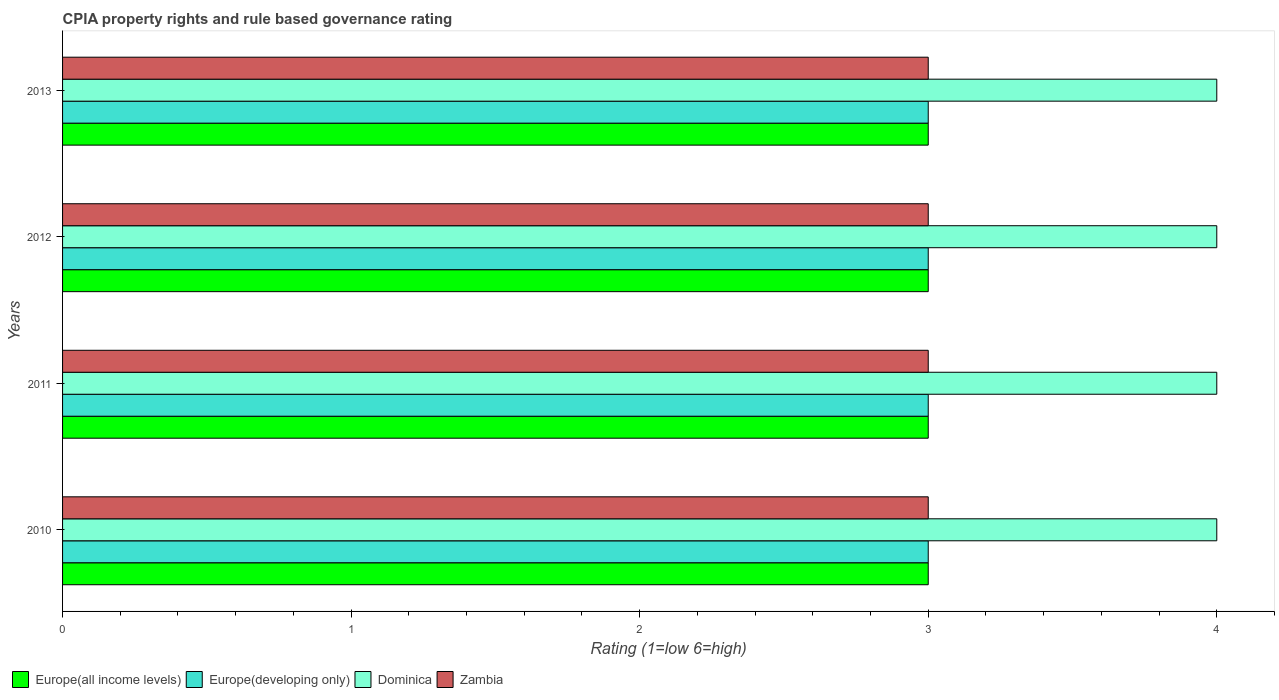How many bars are there on the 4th tick from the bottom?
Provide a succinct answer. 4. What is the label of the 2nd group of bars from the top?
Provide a short and direct response. 2012. What is the CPIA rating in Zambia in 2012?
Keep it short and to the point. 3. Across all years, what is the maximum CPIA rating in Europe(developing only)?
Keep it short and to the point. 3. What is the total CPIA rating in Dominica in the graph?
Keep it short and to the point. 16. In the year 2012, what is the difference between the CPIA rating in Zambia and CPIA rating in Europe(developing only)?
Make the answer very short. 0. In how many years, is the CPIA rating in Zambia greater than 3.4 ?
Keep it short and to the point. 0. What is the ratio of the CPIA rating in Europe(developing only) in 2011 to that in 2013?
Give a very brief answer. 1. Is the difference between the CPIA rating in Zambia in 2010 and 2011 greater than the difference between the CPIA rating in Europe(developing only) in 2010 and 2011?
Keep it short and to the point. No. Is it the case that in every year, the sum of the CPIA rating in Europe(developing only) and CPIA rating in Zambia is greater than the sum of CPIA rating in Europe(all income levels) and CPIA rating in Dominica?
Offer a terse response. No. What does the 2nd bar from the top in 2012 represents?
Give a very brief answer. Dominica. What does the 2nd bar from the bottom in 2010 represents?
Your response must be concise. Europe(developing only). Is it the case that in every year, the sum of the CPIA rating in Dominica and CPIA rating in Zambia is greater than the CPIA rating in Europe(all income levels)?
Ensure brevity in your answer.  Yes. What is the difference between two consecutive major ticks on the X-axis?
Offer a terse response. 1. Are the values on the major ticks of X-axis written in scientific E-notation?
Your answer should be very brief. No. Does the graph contain grids?
Provide a succinct answer. No. How many legend labels are there?
Offer a terse response. 4. How are the legend labels stacked?
Provide a short and direct response. Horizontal. What is the title of the graph?
Your response must be concise. CPIA property rights and rule based governance rating. Does "New Zealand" appear as one of the legend labels in the graph?
Keep it short and to the point. No. What is the Rating (1=low 6=high) of Europe(developing only) in 2010?
Keep it short and to the point. 3. What is the Rating (1=low 6=high) in Zambia in 2010?
Your response must be concise. 3. What is the Rating (1=low 6=high) in Europe(developing only) in 2011?
Offer a very short reply. 3. What is the Rating (1=low 6=high) of Dominica in 2011?
Keep it short and to the point. 4. What is the Rating (1=low 6=high) in Zambia in 2011?
Make the answer very short. 3. What is the Rating (1=low 6=high) of Europe(all income levels) in 2012?
Keep it short and to the point. 3. What is the Rating (1=low 6=high) in Europe(all income levels) in 2013?
Your answer should be very brief. 3. What is the Rating (1=low 6=high) in Zambia in 2013?
Ensure brevity in your answer.  3. Across all years, what is the maximum Rating (1=low 6=high) in Europe(all income levels)?
Your answer should be very brief. 3. Across all years, what is the maximum Rating (1=low 6=high) in Europe(developing only)?
Your answer should be compact. 3. Across all years, what is the maximum Rating (1=low 6=high) of Dominica?
Provide a succinct answer. 4. Across all years, what is the minimum Rating (1=low 6=high) of Zambia?
Ensure brevity in your answer.  3. What is the total Rating (1=low 6=high) of Europe(all income levels) in the graph?
Your answer should be compact. 12. What is the total Rating (1=low 6=high) of Europe(developing only) in the graph?
Offer a very short reply. 12. What is the total Rating (1=low 6=high) in Dominica in the graph?
Offer a terse response. 16. What is the difference between the Rating (1=low 6=high) of Europe(developing only) in 2010 and that in 2011?
Keep it short and to the point. 0. What is the difference between the Rating (1=low 6=high) in Dominica in 2010 and that in 2011?
Your answer should be very brief. 0. What is the difference between the Rating (1=low 6=high) of Zambia in 2010 and that in 2011?
Provide a short and direct response. 0. What is the difference between the Rating (1=low 6=high) in Europe(all income levels) in 2010 and that in 2012?
Keep it short and to the point. 0. What is the difference between the Rating (1=low 6=high) of Europe(developing only) in 2010 and that in 2012?
Give a very brief answer. 0. What is the difference between the Rating (1=low 6=high) of Dominica in 2010 and that in 2012?
Offer a very short reply. 0. What is the difference between the Rating (1=low 6=high) of Europe(all income levels) in 2010 and that in 2013?
Your answer should be very brief. 0. What is the difference between the Rating (1=low 6=high) of Zambia in 2010 and that in 2013?
Give a very brief answer. 0. What is the difference between the Rating (1=low 6=high) in Europe(developing only) in 2011 and that in 2013?
Your response must be concise. 0. What is the difference between the Rating (1=low 6=high) of Europe(developing only) in 2012 and that in 2013?
Offer a very short reply. 0. What is the difference between the Rating (1=low 6=high) of Zambia in 2012 and that in 2013?
Your answer should be compact. 0. What is the difference between the Rating (1=low 6=high) of Europe(all income levels) in 2010 and the Rating (1=low 6=high) of Dominica in 2011?
Your answer should be compact. -1. What is the difference between the Rating (1=low 6=high) of Europe(developing only) in 2010 and the Rating (1=low 6=high) of Zambia in 2011?
Offer a terse response. 0. What is the difference between the Rating (1=low 6=high) in Dominica in 2010 and the Rating (1=low 6=high) in Zambia in 2011?
Make the answer very short. 1. What is the difference between the Rating (1=low 6=high) of Europe(all income levels) in 2010 and the Rating (1=low 6=high) of Europe(developing only) in 2012?
Make the answer very short. 0. What is the difference between the Rating (1=low 6=high) in Europe(developing only) in 2010 and the Rating (1=low 6=high) in Dominica in 2012?
Keep it short and to the point. -1. What is the difference between the Rating (1=low 6=high) of Dominica in 2010 and the Rating (1=low 6=high) of Zambia in 2012?
Offer a very short reply. 1. What is the difference between the Rating (1=low 6=high) in Europe(all income levels) in 2010 and the Rating (1=low 6=high) in Europe(developing only) in 2013?
Give a very brief answer. 0. What is the difference between the Rating (1=low 6=high) of Europe(developing only) in 2010 and the Rating (1=low 6=high) of Zambia in 2013?
Provide a short and direct response. 0. What is the difference between the Rating (1=low 6=high) in Europe(all income levels) in 2011 and the Rating (1=low 6=high) in Europe(developing only) in 2012?
Ensure brevity in your answer.  0. What is the difference between the Rating (1=low 6=high) in Europe(all income levels) in 2011 and the Rating (1=low 6=high) in Dominica in 2012?
Offer a very short reply. -1. What is the difference between the Rating (1=low 6=high) of Europe(developing only) in 2011 and the Rating (1=low 6=high) of Dominica in 2012?
Your answer should be compact. -1. What is the difference between the Rating (1=low 6=high) in Europe(developing only) in 2011 and the Rating (1=low 6=high) in Zambia in 2012?
Your answer should be compact. 0. What is the difference between the Rating (1=low 6=high) of Europe(all income levels) in 2011 and the Rating (1=low 6=high) of Europe(developing only) in 2013?
Offer a terse response. 0. What is the difference between the Rating (1=low 6=high) of Europe(all income levels) in 2011 and the Rating (1=low 6=high) of Dominica in 2013?
Offer a very short reply. -1. What is the difference between the Rating (1=low 6=high) in Europe(all income levels) in 2011 and the Rating (1=low 6=high) in Zambia in 2013?
Offer a very short reply. 0. What is the difference between the Rating (1=low 6=high) of Dominica in 2011 and the Rating (1=low 6=high) of Zambia in 2013?
Provide a succinct answer. 1. What is the difference between the Rating (1=low 6=high) in Europe(all income levels) in 2012 and the Rating (1=low 6=high) in Dominica in 2013?
Provide a succinct answer. -1. What is the difference between the Rating (1=low 6=high) in Europe(all income levels) in 2012 and the Rating (1=low 6=high) in Zambia in 2013?
Offer a terse response. 0. What is the average Rating (1=low 6=high) in Europe(all income levels) per year?
Your answer should be very brief. 3. What is the average Rating (1=low 6=high) in Europe(developing only) per year?
Give a very brief answer. 3. In the year 2010, what is the difference between the Rating (1=low 6=high) in Europe(all income levels) and Rating (1=low 6=high) in Dominica?
Provide a succinct answer. -1. In the year 2010, what is the difference between the Rating (1=low 6=high) in Europe(all income levels) and Rating (1=low 6=high) in Zambia?
Give a very brief answer. 0. In the year 2010, what is the difference between the Rating (1=low 6=high) of Europe(developing only) and Rating (1=low 6=high) of Dominica?
Ensure brevity in your answer.  -1. In the year 2010, what is the difference between the Rating (1=low 6=high) of Europe(developing only) and Rating (1=low 6=high) of Zambia?
Offer a very short reply. 0. In the year 2011, what is the difference between the Rating (1=low 6=high) in Europe(all income levels) and Rating (1=low 6=high) in Dominica?
Provide a short and direct response. -1. In the year 2011, what is the difference between the Rating (1=low 6=high) in Europe(developing only) and Rating (1=low 6=high) in Zambia?
Ensure brevity in your answer.  0. In the year 2011, what is the difference between the Rating (1=low 6=high) of Dominica and Rating (1=low 6=high) of Zambia?
Your answer should be very brief. 1. In the year 2012, what is the difference between the Rating (1=low 6=high) in Dominica and Rating (1=low 6=high) in Zambia?
Keep it short and to the point. 1. In the year 2013, what is the difference between the Rating (1=low 6=high) in Europe(all income levels) and Rating (1=low 6=high) in Dominica?
Your answer should be very brief. -1. In the year 2013, what is the difference between the Rating (1=low 6=high) in Europe(all income levels) and Rating (1=low 6=high) in Zambia?
Make the answer very short. 0. In the year 2013, what is the difference between the Rating (1=low 6=high) in Europe(developing only) and Rating (1=low 6=high) in Zambia?
Your answer should be very brief. 0. In the year 2013, what is the difference between the Rating (1=low 6=high) of Dominica and Rating (1=low 6=high) of Zambia?
Make the answer very short. 1. What is the ratio of the Rating (1=low 6=high) in Europe(all income levels) in 2010 to that in 2011?
Offer a terse response. 1. What is the ratio of the Rating (1=low 6=high) of Europe(developing only) in 2010 to that in 2012?
Your answer should be compact. 1. What is the ratio of the Rating (1=low 6=high) of Dominica in 2010 to that in 2012?
Offer a terse response. 1. What is the ratio of the Rating (1=low 6=high) of Zambia in 2010 to that in 2012?
Provide a succinct answer. 1. What is the ratio of the Rating (1=low 6=high) of Zambia in 2010 to that in 2013?
Your answer should be very brief. 1. What is the ratio of the Rating (1=low 6=high) of Dominica in 2011 to that in 2012?
Provide a succinct answer. 1. What is the ratio of the Rating (1=low 6=high) in Zambia in 2011 to that in 2012?
Offer a terse response. 1. What is the ratio of the Rating (1=low 6=high) of Europe(developing only) in 2012 to that in 2013?
Provide a succinct answer. 1. What is the ratio of the Rating (1=low 6=high) of Dominica in 2012 to that in 2013?
Offer a very short reply. 1. What is the ratio of the Rating (1=low 6=high) of Zambia in 2012 to that in 2013?
Offer a very short reply. 1. What is the difference between the highest and the second highest Rating (1=low 6=high) in Dominica?
Offer a very short reply. 0. What is the difference between the highest and the second highest Rating (1=low 6=high) of Zambia?
Provide a short and direct response. 0. What is the difference between the highest and the lowest Rating (1=low 6=high) in Europe(all income levels)?
Provide a short and direct response. 0. What is the difference between the highest and the lowest Rating (1=low 6=high) of Zambia?
Provide a short and direct response. 0. 